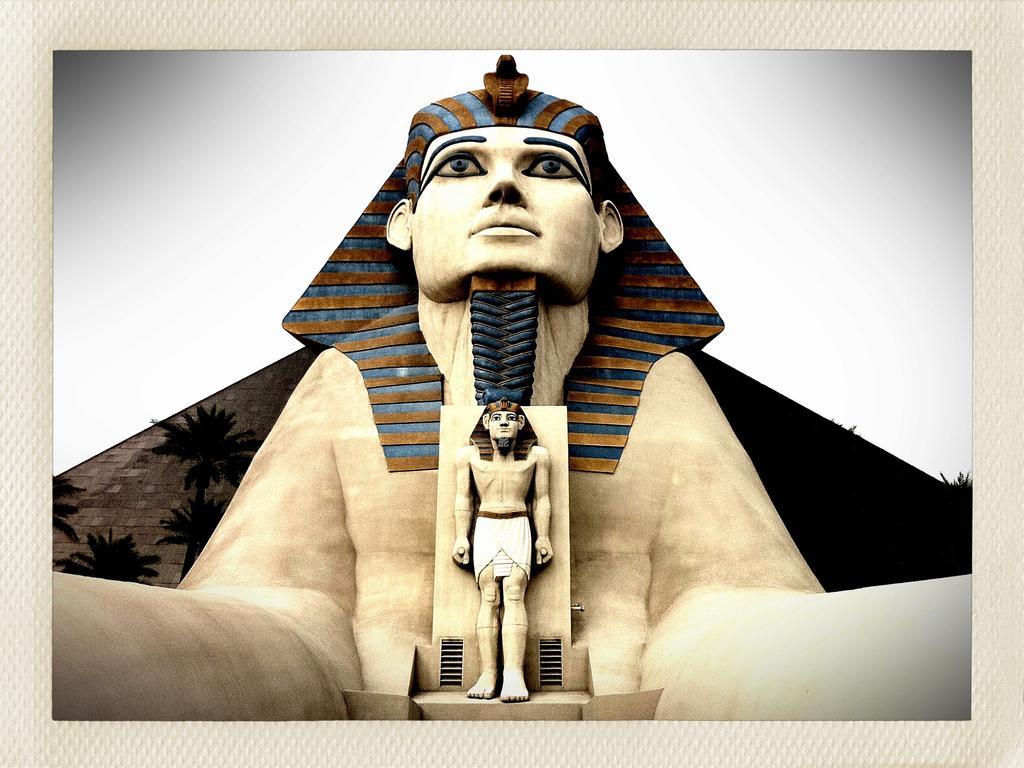How would you summarize this image in a sentence or two? In this picture we can see statues of people and we can see trees. In the background of the image we can see sky. 